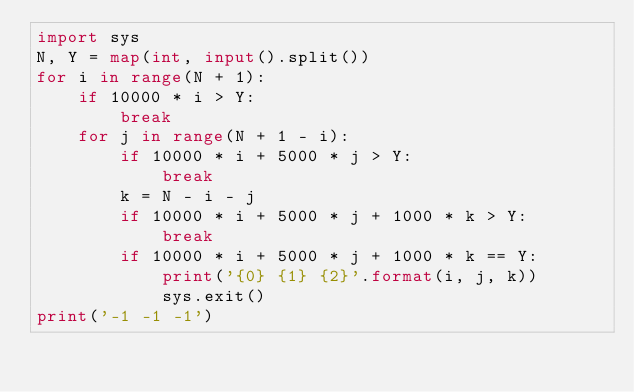Convert code to text. <code><loc_0><loc_0><loc_500><loc_500><_Python_>import sys
N, Y = map(int, input().split())
for i in range(N + 1):
    if 10000 * i > Y:
        break
    for j in range(N + 1 - i):
        if 10000 * i + 5000 * j > Y:
            break
        k = N - i - j
        if 10000 * i + 5000 * j + 1000 * k > Y:
            break
        if 10000 * i + 5000 * j + 1000 * k == Y:
            print('{0} {1} {2}'.format(i, j, k))
            sys.exit()
print('-1 -1 -1')</code> 